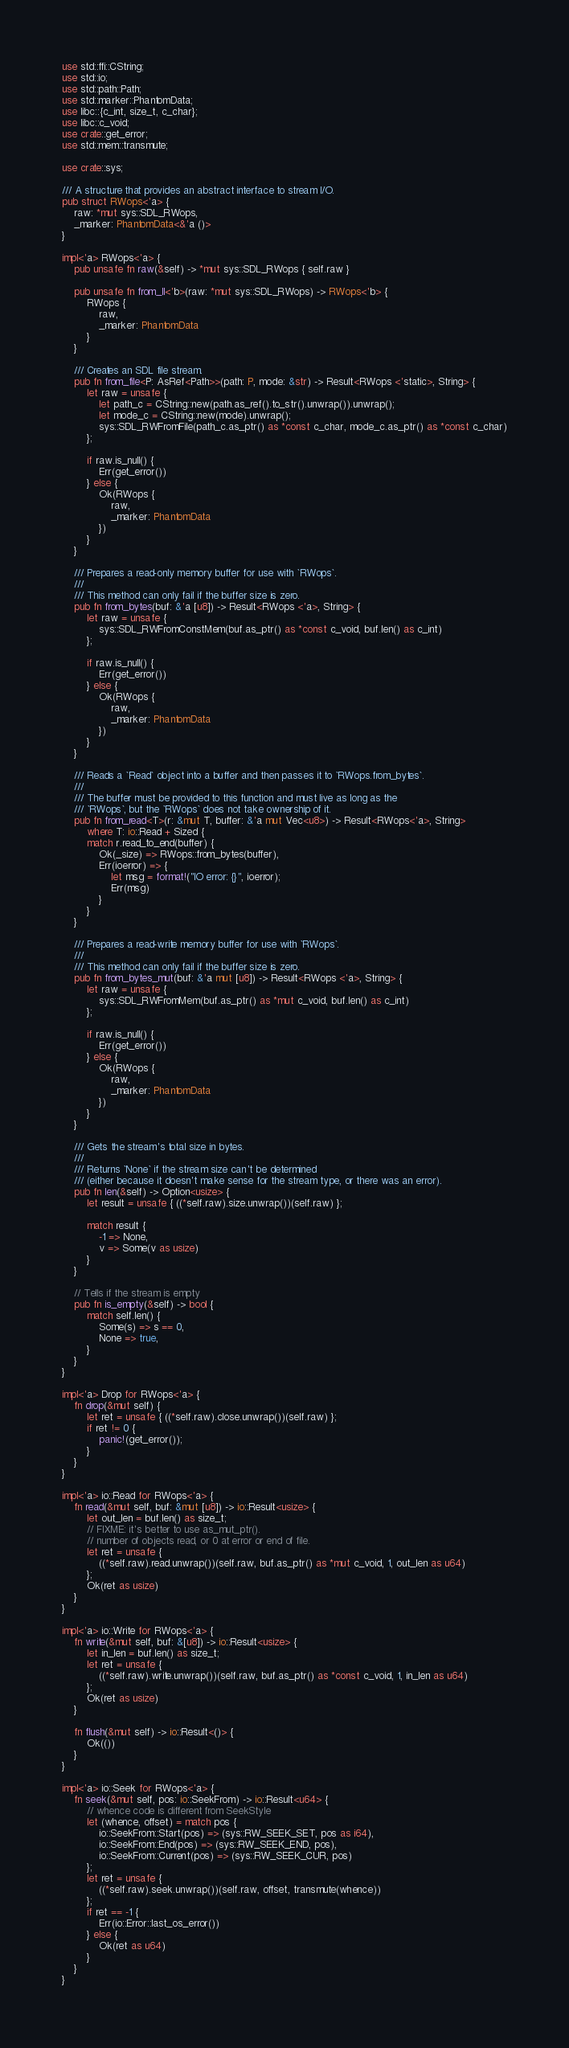<code> <loc_0><loc_0><loc_500><loc_500><_Rust_>use std::ffi::CString;
use std::io;
use std::path::Path;
use std::marker::PhantomData;
use libc::{c_int, size_t, c_char};
use libc::c_void;
use crate::get_error;
use std::mem::transmute;

use crate::sys;

/// A structure that provides an abstract interface to stream I/O.
pub struct RWops<'a> {
    raw: *mut sys::SDL_RWops,
    _marker: PhantomData<&'a ()>
}

impl<'a> RWops<'a> {
    pub unsafe fn raw(&self) -> *mut sys::SDL_RWops { self.raw }

    pub unsafe fn from_ll<'b>(raw: *mut sys::SDL_RWops) -> RWops<'b> {
        RWops {
            raw,
            _marker: PhantomData
        }
    }

    /// Creates an SDL file stream.
    pub fn from_file<P: AsRef<Path>>(path: P, mode: &str) -> Result<RWops <'static>, String> {
        let raw = unsafe {
            let path_c = CString::new(path.as_ref().to_str().unwrap()).unwrap();
            let mode_c = CString::new(mode).unwrap();
            sys::SDL_RWFromFile(path_c.as_ptr() as *const c_char, mode_c.as_ptr() as *const c_char)
        };

        if raw.is_null() {
            Err(get_error())
        } else {
            Ok(RWops {
                raw,
                _marker: PhantomData
            })
        }
    }

    /// Prepares a read-only memory buffer for use with `RWops`.
    ///
    /// This method can only fail if the buffer size is zero.
    pub fn from_bytes(buf: &'a [u8]) -> Result<RWops <'a>, String> {
        let raw = unsafe {
            sys::SDL_RWFromConstMem(buf.as_ptr() as *const c_void, buf.len() as c_int)
        };

        if raw.is_null() {
            Err(get_error())
        } else {
            Ok(RWops {
                raw,
                _marker: PhantomData
            })
        }
    }

    /// Reads a `Read` object into a buffer and then passes it to `RWops.from_bytes`.
    ///
    /// The buffer must be provided to this function and must live as long as the
    /// `RWops`, but the `RWops` does not take ownership of it.
    pub fn from_read<T>(r: &mut T, buffer: &'a mut Vec<u8>) -> Result<RWops<'a>, String>
        where T: io::Read + Sized {
        match r.read_to_end(buffer) {
            Ok(_size) => RWops::from_bytes(buffer),
            Err(ioerror) => {
                let msg = format!("IO error: {}", ioerror);
                Err(msg)
            }
        }
    }

    /// Prepares a read-write memory buffer for use with `RWops`.
    ///
    /// This method can only fail if the buffer size is zero.
    pub fn from_bytes_mut(buf: &'a mut [u8]) -> Result<RWops <'a>, String> {
        let raw = unsafe {
            sys::SDL_RWFromMem(buf.as_ptr() as *mut c_void, buf.len() as c_int)
        };

        if raw.is_null() {
            Err(get_error())
        } else {
            Ok(RWops {
                raw,
                _marker: PhantomData
            })
        }
    }

    /// Gets the stream's total size in bytes.
    ///
    /// Returns `None` if the stream size can't be determined
    /// (either because it doesn't make sense for the stream type, or there was an error).
    pub fn len(&self) -> Option<usize> {
        let result = unsafe { ((*self.raw).size.unwrap())(self.raw) };

        match result {
            -1 => None,
            v => Some(v as usize)
        }
    }

    // Tells if the stream is empty
    pub fn is_empty(&self) -> bool {
        match self.len() {
            Some(s) => s == 0,
            None => true,
        }
    }
}

impl<'a> Drop for RWops<'a> {
    fn drop(&mut self) {
        let ret = unsafe { ((*self.raw).close.unwrap())(self.raw) };
        if ret != 0 {
            panic!(get_error());
        }
    }
}

impl<'a> io::Read for RWops<'a> {
    fn read(&mut self, buf: &mut [u8]) -> io::Result<usize> {
        let out_len = buf.len() as size_t;
        // FIXME: it's better to use as_mut_ptr().
        // number of objects read, or 0 at error or end of file.
        let ret = unsafe {
            ((*self.raw).read.unwrap())(self.raw, buf.as_ptr() as *mut c_void, 1, out_len as u64)
        };
        Ok(ret as usize)
    }
}

impl<'a> io::Write for RWops<'a> {
    fn write(&mut self, buf: &[u8]) -> io::Result<usize> {
        let in_len = buf.len() as size_t;
        let ret = unsafe {
            ((*self.raw).write.unwrap())(self.raw, buf.as_ptr() as *const c_void, 1, in_len as u64)
        };
        Ok(ret as usize)
    }

    fn flush(&mut self) -> io::Result<()> {
        Ok(())
    }
}

impl<'a> io::Seek for RWops<'a> {
    fn seek(&mut self, pos: io::SeekFrom) -> io::Result<u64> {
        // whence code is different from SeekStyle
        let (whence, offset) = match pos {
            io::SeekFrom::Start(pos) => (sys::RW_SEEK_SET, pos as i64),
            io::SeekFrom::End(pos) => (sys::RW_SEEK_END, pos),
            io::SeekFrom::Current(pos) => (sys::RW_SEEK_CUR, pos)
        };
        let ret = unsafe {
            ((*self.raw).seek.unwrap())(self.raw, offset, transmute(whence))
        };
        if ret == -1 {
            Err(io::Error::last_os_error())
        } else {
            Ok(ret as u64)
        }
    }
}
</code> 